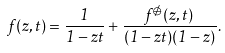Convert formula to latex. <formula><loc_0><loc_0><loc_500><loc_500>f ( z , t ) = \frac { 1 } { 1 - z t } + \frac { f ^ { \not \ominus } ( z , t ) } { ( 1 - z t ) ( 1 - z ) } .</formula> 